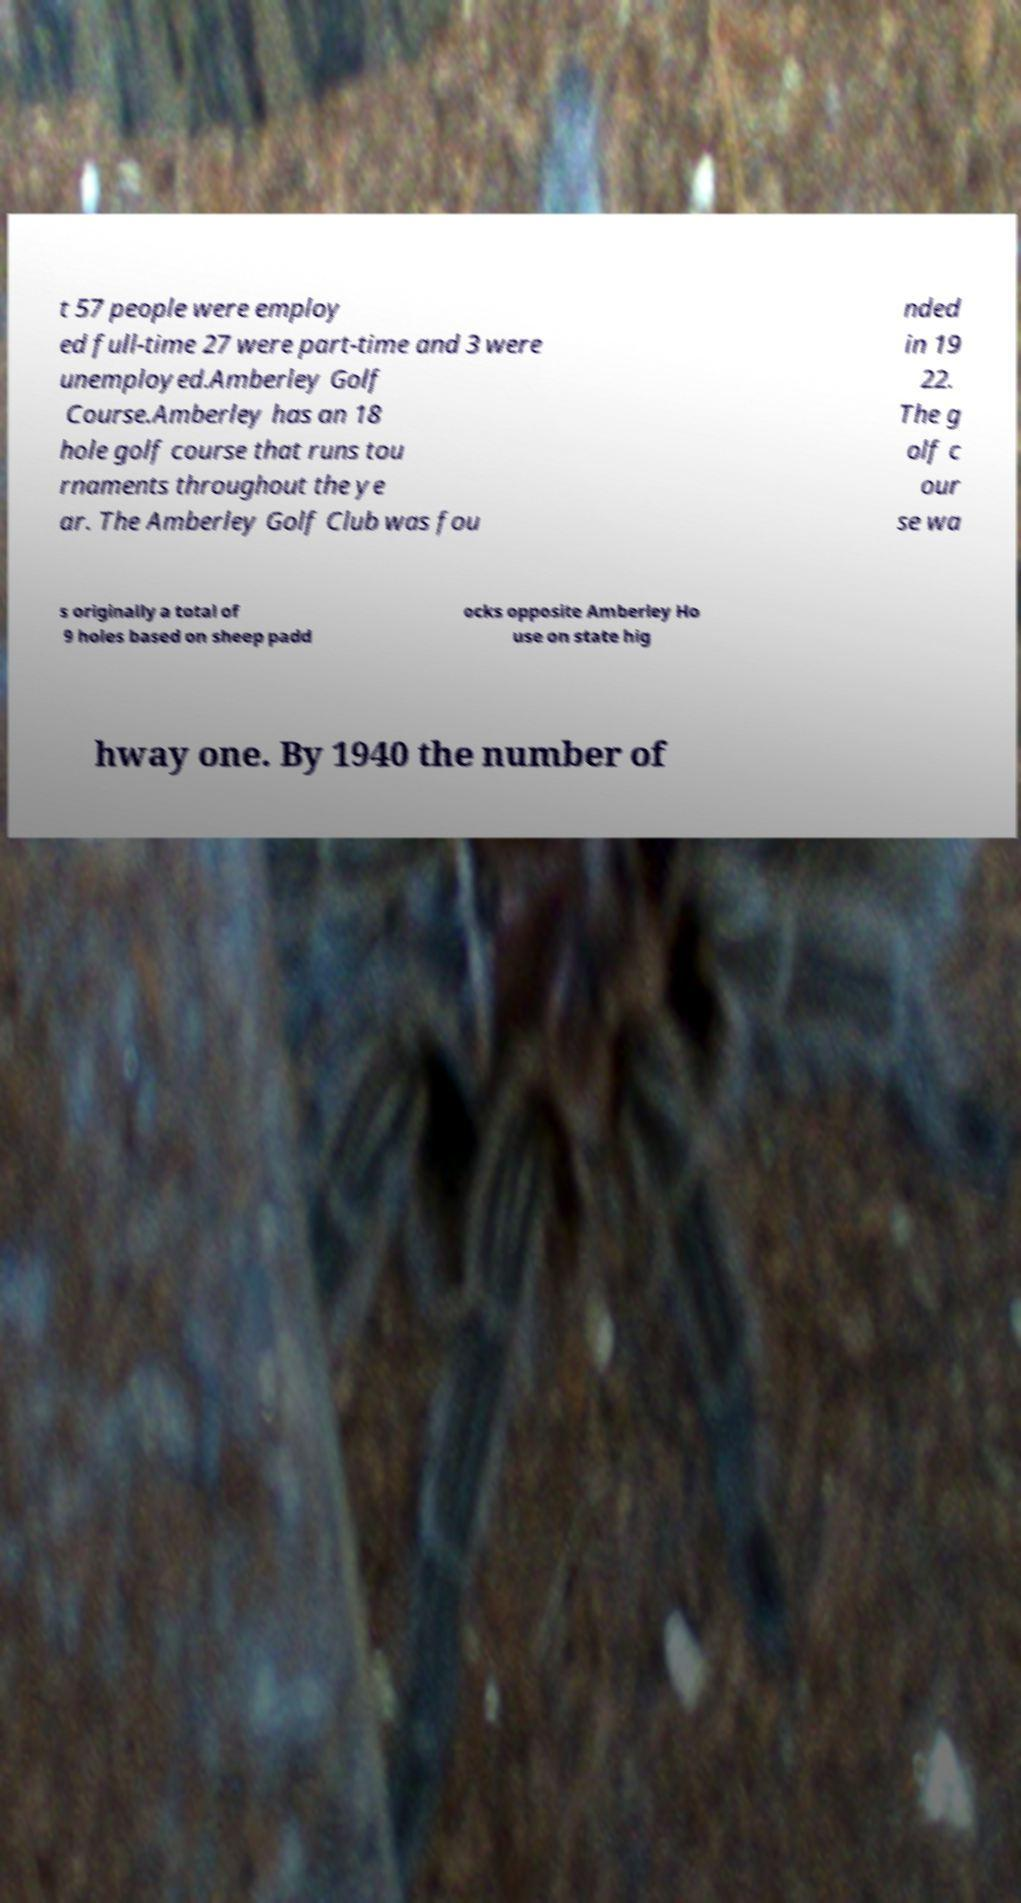Could you extract and type out the text from this image? t 57 people were employ ed full-time 27 were part-time and 3 were unemployed.Amberley Golf Course.Amberley has an 18 hole golf course that runs tou rnaments throughout the ye ar. The Amberley Golf Club was fou nded in 19 22. The g olf c our se wa s originally a total of 9 holes based on sheep padd ocks opposite Amberley Ho use on state hig hway one. By 1940 the number of 